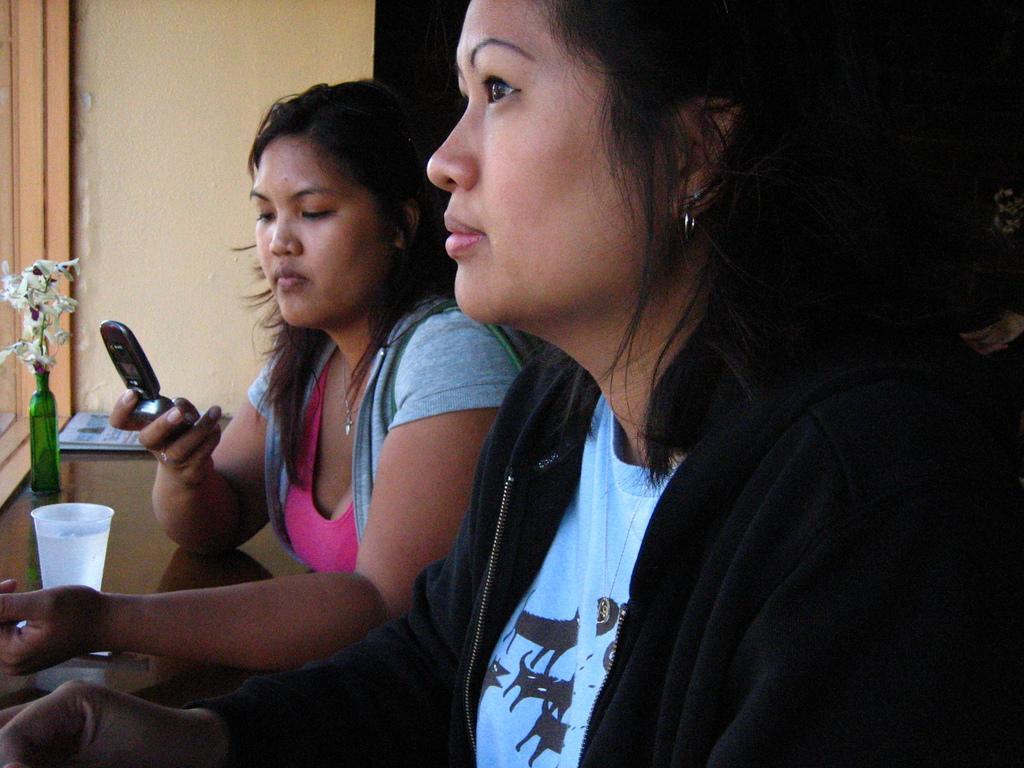Describe this image in one or two sentences. In the foreground of this image, there are two women and a woman is holding a mobile. On the left, there is a glass, flower vase and a book on the surface and it seems like near a window and the background image is dark. 